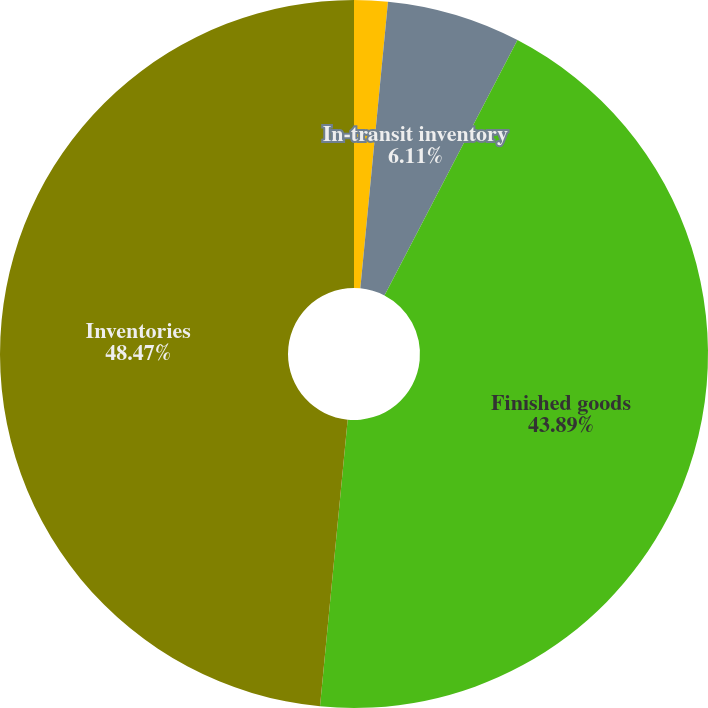Convert chart to OTSL. <chart><loc_0><loc_0><loc_500><loc_500><pie_chart><fcel>Raw materials and work in<fcel>In-transit inventory<fcel>Finished goods<fcel>Inventories<nl><fcel>1.53%<fcel>6.11%<fcel>43.89%<fcel>48.47%<nl></chart> 